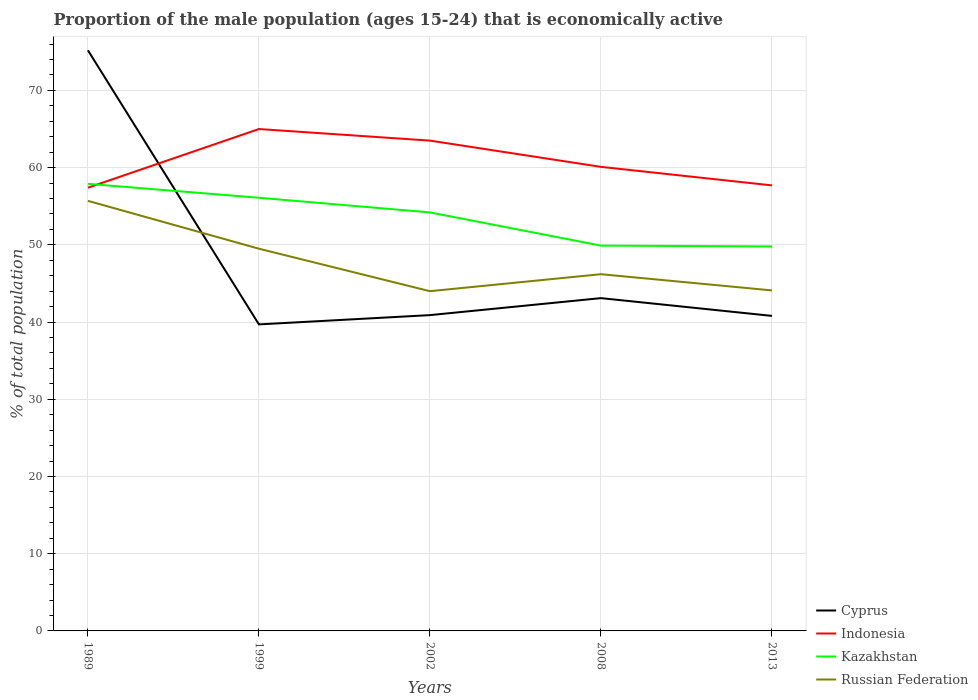How many different coloured lines are there?
Make the answer very short. 4. Is the number of lines equal to the number of legend labels?
Your response must be concise. Yes. Across all years, what is the maximum proportion of the male population that is economically active in Indonesia?
Your answer should be compact. 57.4. What is the total proportion of the male population that is economically active in Russian Federation in the graph?
Your answer should be very brief. -2.2. What is the difference between the highest and the second highest proportion of the male population that is economically active in Indonesia?
Provide a succinct answer. 7.6. How many years are there in the graph?
Your response must be concise. 5. What is the difference between two consecutive major ticks on the Y-axis?
Offer a terse response. 10. Does the graph contain any zero values?
Your response must be concise. No. Does the graph contain grids?
Your answer should be very brief. Yes. What is the title of the graph?
Your answer should be very brief. Proportion of the male population (ages 15-24) that is economically active. Does "Syrian Arab Republic" appear as one of the legend labels in the graph?
Provide a short and direct response. No. What is the label or title of the Y-axis?
Provide a short and direct response. % of total population. What is the % of total population of Cyprus in 1989?
Provide a short and direct response. 75.2. What is the % of total population of Indonesia in 1989?
Offer a very short reply. 57.4. What is the % of total population of Kazakhstan in 1989?
Provide a succinct answer. 57.9. What is the % of total population of Russian Federation in 1989?
Make the answer very short. 55.7. What is the % of total population in Cyprus in 1999?
Keep it short and to the point. 39.7. What is the % of total population of Indonesia in 1999?
Offer a terse response. 65. What is the % of total population of Kazakhstan in 1999?
Offer a terse response. 56.1. What is the % of total population of Russian Federation in 1999?
Offer a very short reply. 49.5. What is the % of total population in Cyprus in 2002?
Your answer should be very brief. 40.9. What is the % of total population of Indonesia in 2002?
Your response must be concise. 63.5. What is the % of total population in Kazakhstan in 2002?
Give a very brief answer. 54.2. What is the % of total population in Russian Federation in 2002?
Provide a short and direct response. 44. What is the % of total population in Cyprus in 2008?
Offer a terse response. 43.1. What is the % of total population in Indonesia in 2008?
Your response must be concise. 60.1. What is the % of total population of Kazakhstan in 2008?
Ensure brevity in your answer.  49.9. What is the % of total population in Russian Federation in 2008?
Give a very brief answer. 46.2. What is the % of total population of Cyprus in 2013?
Your answer should be compact. 40.8. What is the % of total population of Indonesia in 2013?
Give a very brief answer. 57.7. What is the % of total population in Kazakhstan in 2013?
Provide a short and direct response. 49.8. What is the % of total population of Russian Federation in 2013?
Ensure brevity in your answer.  44.1. Across all years, what is the maximum % of total population of Cyprus?
Offer a terse response. 75.2. Across all years, what is the maximum % of total population in Kazakhstan?
Your answer should be very brief. 57.9. Across all years, what is the maximum % of total population in Russian Federation?
Keep it short and to the point. 55.7. Across all years, what is the minimum % of total population of Cyprus?
Make the answer very short. 39.7. Across all years, what is the minimum % of total population in Indonesia?
Your answer should be very brief. 57.4. Across all years, what is the minimum % of total population in Kazakhstan?
Your answer should be compact. 49.8. Across all years, what is the minimum % of total population of Russian Federation?
Ensure brevity in your answer.  44. What is the total % of total population of Cyprus in the graph?
Offer a terse response. 239.7. What is the total % of total population of Indonesia in the graph?
Ensure brevity in your answer.  303.7. What is the total % of total population of Kazakhstan in the graph?
Give a very brief answer. 267.9. What is the total % of total population in Russian Federation in the graph?
Keep it short and to the point. 239.5. What is the difference between the % of total population in Cyprus in 1989 and that in 1999?
Give a very brief answer. 35.5. What is the difference between the % of total population of Indonesia in 1989 and that in 1999?
Keep it short and to the point. -7.6. What is the difference between the % of total population of Kazakhstan in 1989 and that in 1999?
Keep it short and to the point. 1.8. What is the difference between the % of total population in Cyprus in 1989 and that in 2002?
Your response must be concise. 34.3. What is the difference between the % of total population of Kazakhstan in 1989 and that in 2002?
Offer a very short reply. 3.7. What is the difference between the % of total population of Cyprus in 1989 and that in 2008?
Ensure brevity in your answer.  32.1. What is the difference between the % of total population of Cyprus in 1989 and that in 2013?
Make the answer very short. 34.4. What is the difference between the % of total population in Indonesia in 1989 and that in 2013?
Your answer should be compact. -0.3. What is the difference between the % of total population of Indonesia in 1999 and that in 2002?
Make the answer very short. 1.5. What is the difference between the % of total population in Cyprus in 1999 and that in 2013?
Your answer should be very brief. -1.1. What is the difference between the % of total population in Indonesia in 1999 and that in 2013?
Give a very brief answer. 7.3. What is the difference between the % of total population of Russian Federation in 1999 and that in 2013?
Give a very brief answer. 5.4. What is the difference between the % of total population in Kazakhstan in 2002 and that in 2008?
Keep it short and to the point. 4.3. What is the difference between the % of total population of Russian Federation in 2002 and that in 2008?
Your response must be concise. -2.2. What is the difference between the % of total population of Cyprus in 2002 and that in 2013?
Keep it short and to the point. 0.1. What is the difference between the % of total population of Indonesia in 2002 and that in 2013?
Make the answer very short. 5.8. What is the difference between the % of total population of Kazakhstan in 2002 and that in 2013?
Make the answer very short. 4.4. What is the difference between the % of total population in Russian Federation in 2002 and that in 2013?
Offer a terse response. -0.1. What is the difference between the % of total population in Cyprus in 2008 and that in 2013?
Provide a succinct answer. 2.3. What is the difference between the % of total population of Indonesia in 2008 and that in 2013?
Keep it short and to the point. 2.4. What is the difference between the % of total population of Cyprus in 1989 and the % of total population of Kazakhstan in 1999?
Your response must be concise. 19.1. What is the difference between the % of total population in Cyprus in 1989 and the % of total population in Russian Federation in 1999?
Make the answer very short. 25.7. What is the difference between the % of total population in Indonesia in 1989 and the % of total population in Kazakhstan in 1999?
Your answer should be compact. 1.3. What is the difference between the % of total population of Cyprus in 1989 and the % of total population of Russian Federation in 2002?
Ensure brevity in your answer.  31.2. What is the difference between the % of total population of Cyprus in 1989 and the % of total population of Kazakhstan in 2008?
Give a very brief answer. 25.3. What is the difference between the % of total population in Cyprus in 1989 and the % of total population in Russian Federation in 2008?
Provide a succinct answer. 29. What is the difference between the % of total population of Indonesia in 1989 and the % of total population of Russian Federation in 2008?
Provide a succinct answer. 11.2. What is the difference between the % of total population of Cyprus in 1989 and the % of total population of Kazakhstan in 2013?
Make the answer very short. 25.4. What is the difference between the % of total population of Cyprus in 1989 and the % of total population of Russian Federation in 2013?
Your response must be concise. 31.1. What is the difference between the % of total population of Indonesia in 1989 and the % of total population of Kazakhstan in 2013?
Provide a short and direct response. 7.6. What is the difference between the % of total population of Indonesia in 1989 and the % of total population of Russian Federation in 2013?
Provide a short and direct response. 13.3. What is the difference between the % of total population of Cyprus in 1999 and the % of total population of Indonesia in 2002?
Offer a very short reply. -23.8. What is the difference between the % of total population of Cyprus in 1999 and the % of total population of Kazakhstan in 2002?
Your response must be concise. -14.5. What is the difference between the % of total population of Indonesia in 1999 and the % of total population of Russian Federation in 2002?
Offer a very short reply. 21. What is the difference between the % of total population of Cyprus in 1999 and the % of total population of Indonesia in 2008?
Provide a succinct answer. -20.4. What is the difference between the % of total population of Cyprus in 1999 and the % of total population of Kazakhstan in 2008?
Ensure brevity in your answer.  -10.2. What is the difference between the % of total population in Cyprus in 1999 and the % of total population in Russian Federation in 2008?
Give a very brief answer. -6.5. What is the difference between the % of total population in Indonesia in 1999 and the % of total population in Kazakhstan in 2008?
Make the answer very short. 15.1. What is the difference between the % of total population of Indonesia in 1999 and the % of total population of Russian Federation in 2008?
Make the answer very short. 18.8. What is the difference between the % of total population in Cyprus in 1999 and the % of total population in Indonesia in 2013?
Offer a terse response. -18. What is the difference between the % of total population in Cyprus in 1999 and the % of total population in Kazakhstan in 2013?
Ensure brevity in your answer.  -10.1. What is the difference between the % of total population in Cyprus in 1999 and the % of total population in Russian Federation in 2013?
Make the answer very short. -4.4. What is the difference between the % of total population in Indonesia in 1999 and the % of total population in Russian Federation in 2013?
Make the answer very short. 20.9. What is the difference between the % of total population in Cyprus in 2002 and the % of total population in Indonesia in 2008?
Your answer should be very brief. -19.2. What is the difference between the % of total population of Cyprus in 2002 and the % of total population of Russian Federation in 2008?
Offer a very short reply. -5.3. What is the difference between the % of total population of Kazakhstan in 2002 and the % of total population of Russian Federation in 2008?
Give a very brief answer. 8. What is the difference between the % of total population of Cyprus in 2002 and the % of total population of Indonesia in 2013?
Offer a very short reply. -16.8. What is the difference between the % of total population in Cyprus in 2008 and the % of total population in Indonesia in 2013?
Provide a short and direct response. -14.6. What is the difference between the % of total population of Cyprus in 2008 and the % of total population of Kazakhstan in 2013?
Offer a terse response. -6.7. What is the difference between the % of total population of Cyprus in 2008 and the % of total population of Russian Federation in 2013?
Provide a succinct answer. -1. What is the difference between the % of total population in Indonesia in 2008 and the % of total population in Russian Federation in 2013?
Make the answer very short. 16. What is the average % of total population of Cyprus per year?
Provide a succinct answer. 47.94. What is the average % of total population of Indonesia per year?
Your answer should be compact. 60.74. What is the average % of total population in Kazakhstan per year?
Your response must be concise. 53.58. What is the average % of total population of Russian Federation per year?
Your response must be concise. 47.9. In the year 1989, what is the difference between the % of total population in Cyprus and % of total population in Russian Federation?
Your answer should be very brief. 19.5. In the year 1999, what is the difference between the % of total population in Cyprus and % of total population in Indonesia?
Make the answer very short. -25.3. In the year 1999, what is the difference between the % of total population of Cyprus and % of total population of Kazakhstan?
Make the answer very short. -16.4. In the year 1999, what is the difference between the % of total population in Indonesia and % of total population in Kazakhstan?
Your answer should be very brief. 8.9. In the year 1999, what is the difference between the % of total population of Indonesia and % of total population of Russian Federation?
Your answer should be very brief. 15.5. In the year 2002, what is the difference between the % of total population of Cyprus and % of total population of Indonesia?
Your response must be concise. -22.6. In the year 2002, what is the difference between the % of total population in Cyprus and % of total population in Kazakhstan?
Your answer should be very brief. -13.3. In the year 2002, what is the difference between the % of total population of Cyprus and % of total population of Russian Federation?
Your response must be concise. -3.1. In the year 2002, what is the difference between the % of total population of Indonesia and % of total population of Russian Federation?
Provide a short and direct response. 19.5. In the year 2002, what is the difference between the % of total population of Kazakhstan and % of total population of Russian Federation?
Offer a terse response. 10.2. In the year 2008, what is the difference between the % of total population of Cyprus and % of total population of Kazakhstan?
Provide a short and direct response. -6.8. In the year 2008, what is the difference between the % of total population of Cyprus and % of total population of Russian Federation?
Provide a short and direct response. -3.1. In the year 2008, what is the difference between the % of total population of Kazakhstan and % of total population of Russian Federation?
Provide a succinct answer. 3.7. In the year 2013, what is the difference between the % of total population of Cyprus and % of total population of Indonesia?
Provide a succinct answer. -16.9. In the year 2013, what is the difference between the % of total population in Cyprus and % of total population in Russian Federation?
Your answer should be very brief. -3.3. In the year 2013, what is the difference between the % of total population of Indonesia and % of total population of Kazakhstan?
Your answer should be compact. 7.9. In the year 2013, what is the difference between the % of total population in Indonesia and % of total population in Russian Federation?
Your answer should be compact. 13.6. In the year 2013, what is the difference between the % of total population of Kazakhstan and % of total population of Russian Federation?
Offer a very short reply. 5.7. What is the ratio of the % of total population in Cyprus in 1989 to that in 1999?
Your answer should be compact. 1.89. What is the ratio of the % of total population in Indonesia in 1989 to that in 1999?
Make the answer very short. 0.88. What is the ratio of the % of total population in Kazakhstan in 1989 to that in 1999?
Make the answer very short. 1.03. What is the ratio of the % of total population of Russian Federation in 1989 to that in 1999?
Your answer should be compact. 1.13. What is the ratio of the % of total population of Cyprus in 1989 to that in 2002?
Your response must be concise. 1.84. What is the ratio of the % of total population of Indonesia in 1989 to that in 2002?
Your answer should be very brief. 0.9. What is the ratio of the % of total population of Kazakhstan in 1989 to that in 2002?
Offer a terse response. 1.07. What is the ratio of the % of total population in Russian Federation in 1989 to that in 2002?
Your response must be concise. 1.27. What is the ratio of the % of total population in Cyprus in 1989 to that in 2008?
Your response must be concise. 1.74. What is the ratio of the % of total population in Indonesia in 1989 to that in 2008?
Give a very brief answer. 0.96. What is the ratio of the % of total population in Kazakhstan in 1989 to that in 2008?
Provide a succinct answer. 1.16. What is the ratio of the % of total population in Russian Federation in 1989 to that in 2008?
Your response must be concise. 1.21. What is the ratio of the % of total population of Cyprus in 1989 to that in 2013?
Keep it short and to the point. 1.84. What is the ratio of the % of total population in Indonesia in 1989 to that in 2013?
Offer a very short reply. 0.99. What is the ratio of the % of total population in Kazakhstan in 1989 to that in 2013?
Offer a very short reply. 1.16. What is the ratio of the % of total population in Russian Federation in 1989 to that in 2013?
Provide a short and direct response. 1.26. What is the ratio of the % of total population of Cyprus in 1999 to that in 2002?
Make the answer very short. 0.97. What is the ratio of the % of total population of Indonesia in 1999 to that in 2002?
Your response must be concise. 1.02. What is the ratio of the % of total population in Kazakhstan in 1999 to that in 2002?
Your answer should be very brief. 1.04. What is the ratio of the % of total population in Russian Federation in 1999 to that in 2002?
Make the answer very short. 1.12. What is the ratio of the % of total population in Cyprus in 1999 to that in 2008?
Offer a terse response. 0.92. What is the ratio of the % of total population of Indonesia in 1999 to that in 2008?
Offer a very short reply. 1.08. What is the ratio of the % of total population in Kazakhstan in 1999 to that in 2008?
Offer a terse response. 1.12. What is the ratio of the % of total population of Russian Federation in 1999 to that in 2008?
Provide a succinct answer. 1.07. What is the ratio of the % of total population in Cyprus in 1999 to that in 2013?
Your response must be concise. 0.97. What is the ratio of the % of total population of Indonesia in 1999 to that in 2013?
Your answer should be very brief. 1.13. What is the ratio of the % of total population of Kazakhstan in 1999 to that in 2013?
Your answer should be compact. 1.13. What is the ratio of the % of total population of Russian Federation in 1999 to that in 2013?
Offer a very short reply. 1.12. What is the ratio of the % of total population in Cyprus in 2002 to that in 2008?
Your answer should be very brief. 0.95. What is the ratio of the % of total population of Indonesia in 2002 to that in 2008?
Provide a short and direct response. 1.06. What is the ratio of the % of total population in Kazakhstan in 2002 to that in 2008?
Provide a short and direct response. 1.09. What is the ratio of the % of total population in Russian Federation in 2002 to that in 2008?
Your answer should be very brief. 0.95. What is the ratio of the % of total population of Indonesia in 2002 to that in 2013?
Your answer should be compact. 1.1. What is the ratio of the % of total population of Kazakhstan in 2002 to that in 2013?
Your answer should be compact. 1.09. What is the ratio of the % of total population in Russian Federation in 2002 to that in 2013?
Ensure brevity in your answer.  1. What is the ratio of the % of total population of Cyprus in 2008 to that in 2013?
Offer a very short reply. 1.06. What is the ratio of the % of total population in Indonesia in 2008 to that in 2013?
Keep it short and to the point. 1.04. What is the ratio of the % of total population in Russian Federation in 2008 to that in 2013?
Keep it short and to the point. 1.05. What is the difference between the highest and the second highest % of total population in Cyprus?
Give a very brief answer. 32.1. What is the difference between the highest and the second highest % of total population in Indonesia?
Provide a short and direct response. 1.5. What is the difference between the highest and the second highest % of total population in Kazakhstan?
Keep it short and to the point. 1.8. What is the difference between the highest and the lowest % of total population in Cyprus?
Your answer should be compact. 35.5. What is the difference between the highest and the lowest % of total population of Indonesia?
Keep it short and to the point. 7.6. What is the difference between the highest and the lowest % of total population in Kazakhstan?
Provide a short and direct response. 8.1. What is the difference between the highest and the lowest % of total population of Russian Federation?
Your response must be concise. 11.7. 